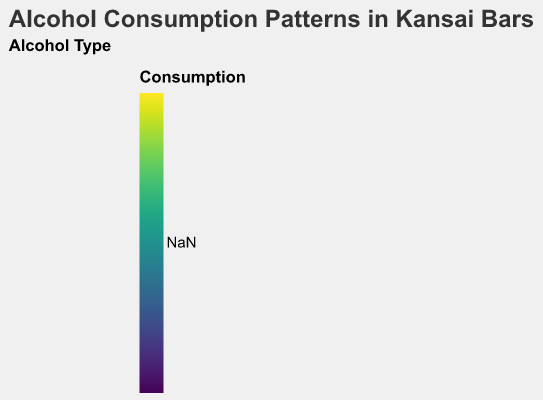What is the title of the heatmap? The title of the heatmap is usually presented at the top center of the figure. In this case, it reads "Alcohol Consumption Patterns in Kansai Bars."
Answer: Alcohol Consumption Patterns in Kansai Bars Which drink has the highest consumption at 18:00 on Friday? By looking at the cells for Beer, Wine, Whiskey, Sake, and Cocktails at 18:00 on Friday, we can compare their colors to find the one with the highest value. Beer has a value of 30, which is the highest.
Answer: Beer On which day and time does wine have the highest consumption? We need to identify the cell for Wine with the highest color intensity. Wine has the highest value of 30 at 22:00 on Saturday.
Answer: Saturday, 22:00 What is the average Whiskey consumption on Mondays between 18:00 and 22:00? Add the Whiskey values for each hour on Monday (15+20+25+28+30) and divide by the number of data points (5). The sum is 118, and dividing by 5 gives an average of 23.6.
Answer: 23.6 Compare the consumption of Sake between Wednesday 21:00 and Thursday 21:00. Which is higher? Check the Sake values at 21:00 on Wednesday (18) and Thursday (19). Thursday's consumption (19) is higher than Wednesday's (18).
Answer: Thursday What is the total Cocktails consumption on Sundays? Add the Cocktails values at all times on Sunday (26+28+32+36+39). The total sum is 161.
Answer: 161 Which day has the least beer consumption at 22:00? Compare the Beer values at 22:00 for all days. Wednesday has the least consumption at that time with a value of 45.
Answer: Wednesday How does the Wine consumption trend change from Monday to Friday at 20:00? Observe the color gradient for Wine at 20:00 from Monday to Friday: it starts at 12 on Monday and increases progressively to 21 on Friday, showing an upward trend.
Answer: Increasing What is the difference in Whiskey consumption between 21:00 and 22:00 on a Saturday? Subtract the Whiskey value at 21:00 (32) from the value at 22:00 (36). The difference is 4.
Answer: 4 Which drink shows a strong consumption pattern late in the evening (22:00) across all days? By comparing the color intensities of all drinks at 22:00 across all days, Beer consistently shows stronger patterns compared to the others.
Answer: Beer 